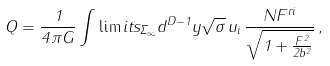<formula> <loc_0><loc_0><loc_500><loc_500>Q = \frac { 1 } { 4 \pi G } \int \lim i t s _ { \Sigma _ { \infty } } d ^ { D - 1 } y \sqrt { \sigma } \, u _ { i } \, \frac { N F ^ { r i } } { \sqrt { 1 + \frac { F ^ { 2 } } { 2 b ^ { 2 } } } } \, ,</formula> 